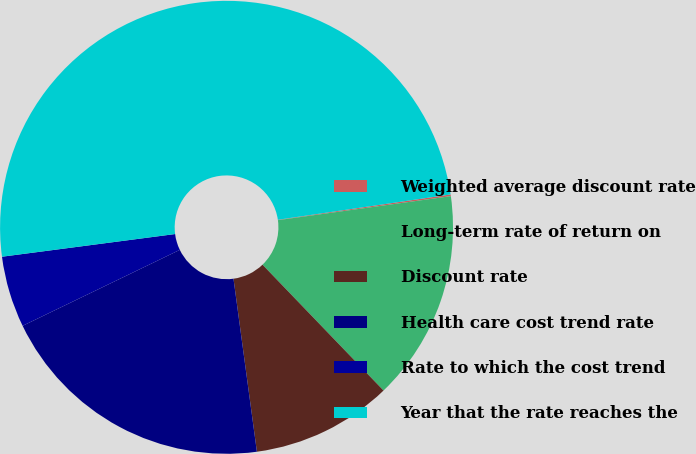Convert chart to OTSL. <chart><loc_0><loc_0><loc_500><loc_500><pie_chart><fcel>Weighted average discount rate<fcel>Long-term rate of return on<fcel>Discount rate<fcel>Health care cost trend rate<fcel>Rate to which the cost trend<fcel>Year that the rate reaches the<nl><fcel>0.12%<fcel>15.01%<fcel>10.05%<fcel>19.98%<fcel>5.09%<fcel>49.76%<nl></chart> 